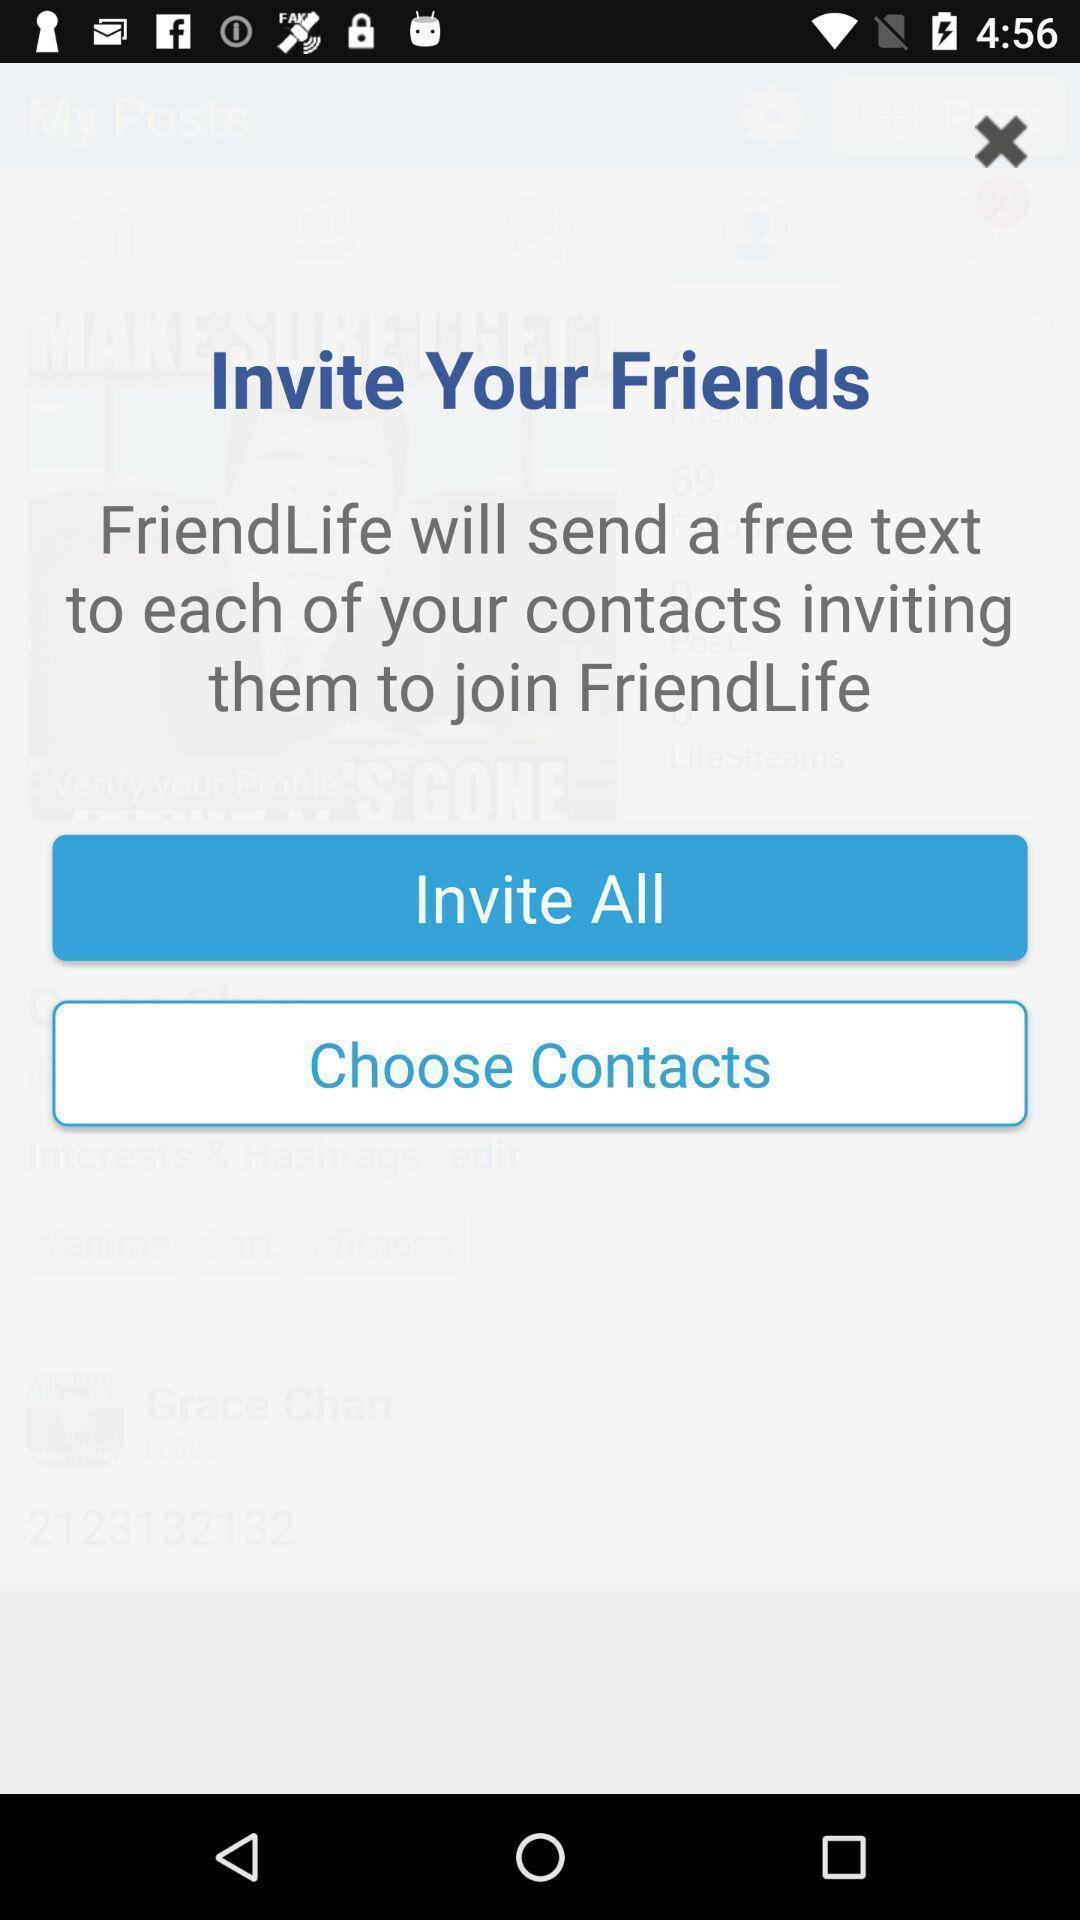Tell me about the visual elements in this screen capture. Page displays to invite friends in app. 